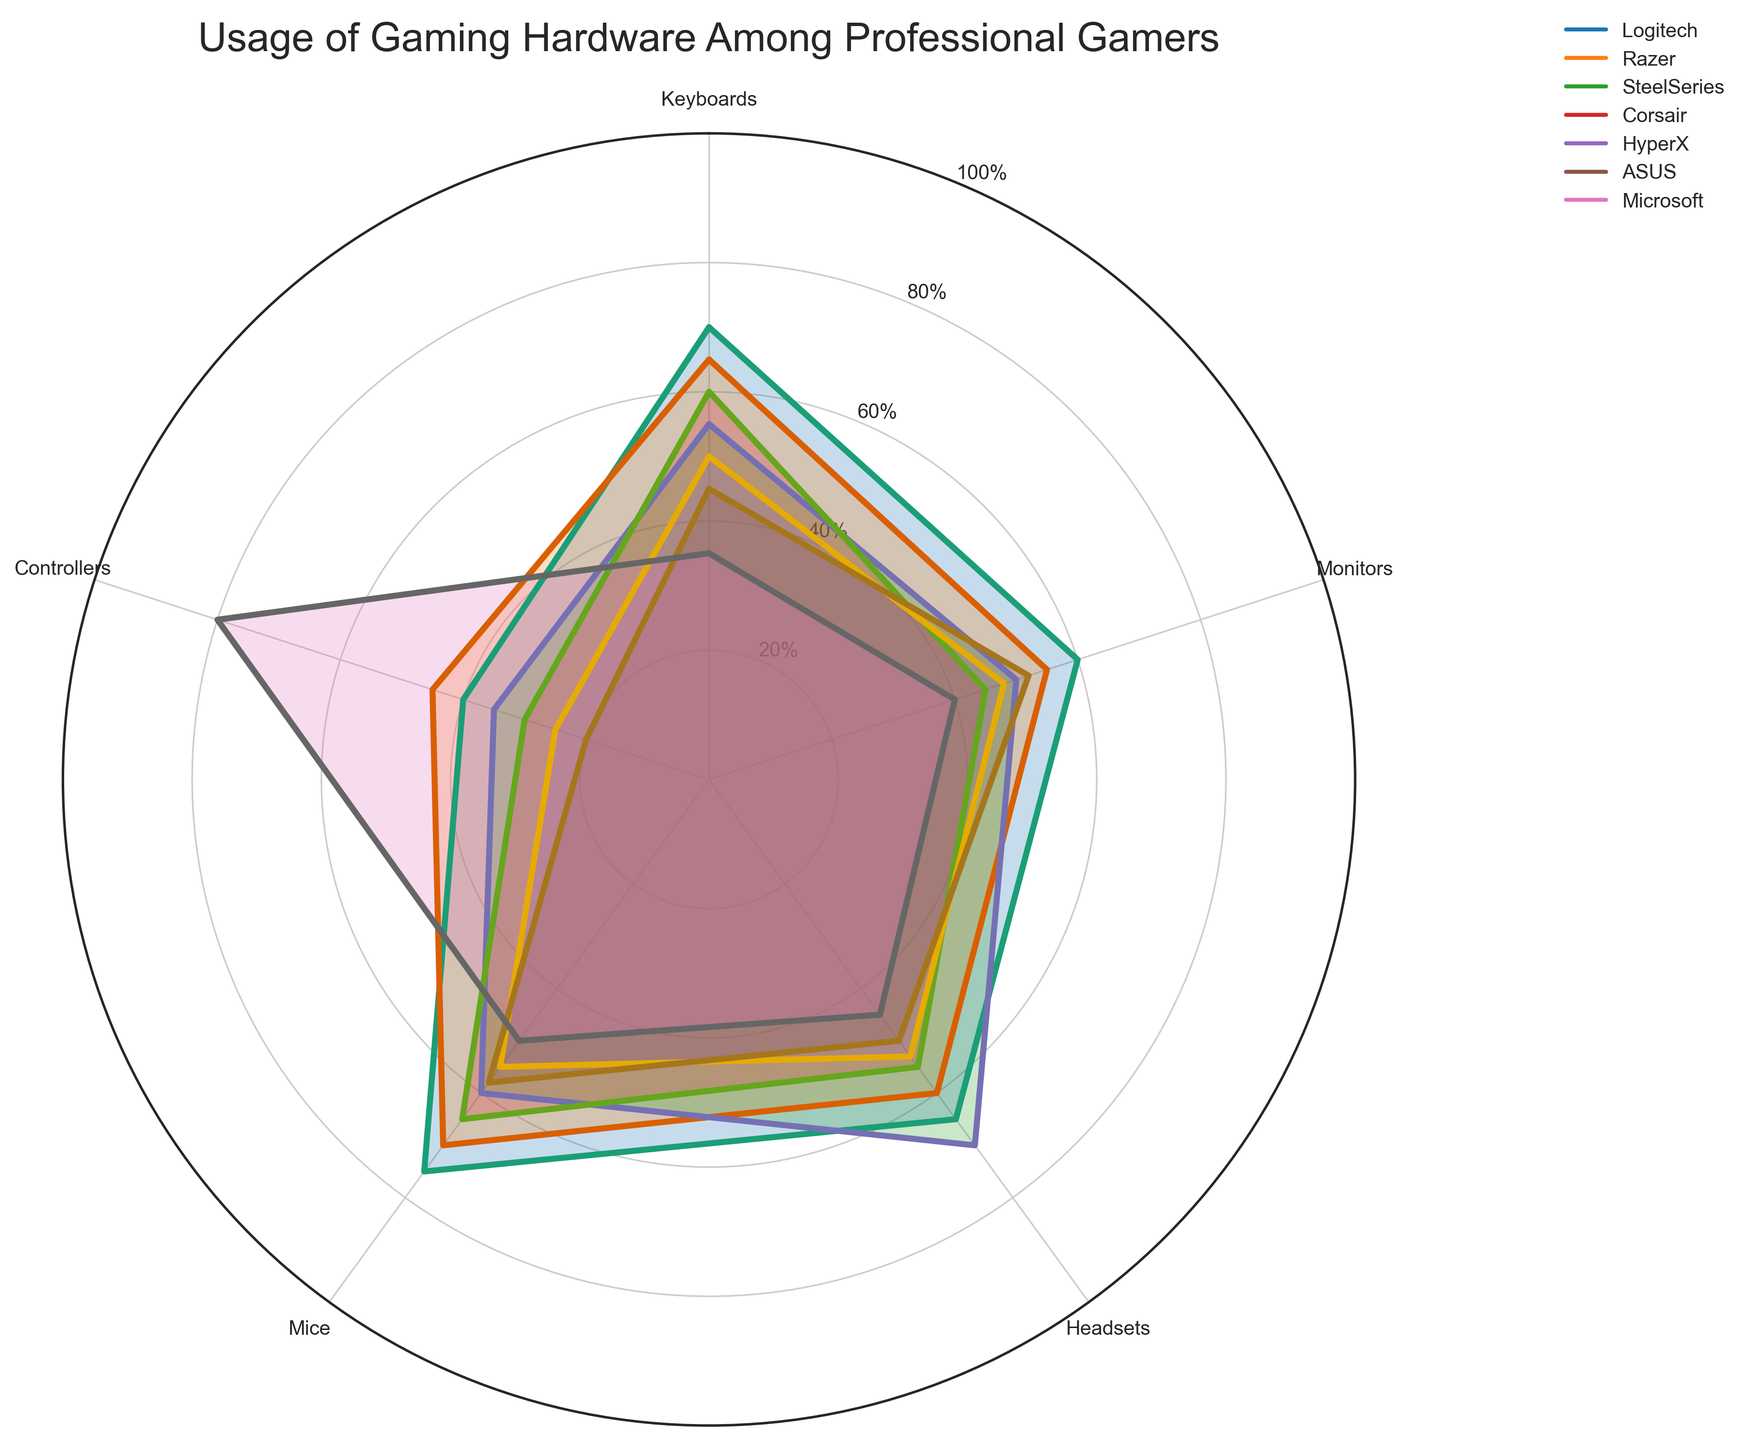How many categories of gaming hardware and peripherals are shown in the figure? The figure displays the different categories as labels around the polar chart. Counting these labels shows how many categories are present. There are five distinct categories: Keyboards, Monitors, Headsets, Mice, and Controllers.
Answer: 5 Which brand is the most popular for gaming keyboards among professional gamers? The angle representing 'Keyboards' shows the percentage usage for each brand. The brand with the highest value at this angle is Logitech, with a usage percentage of 70%.
Answer: Logitech Which category does Microsoft dominate in professional gaming hardware and peripherals? By examining the angles for each category and looking for the highest percentage value for Microsoft, we see that Microsoft leads in 'Controllers' with a percentage of 80%.
Answer: Controllers How does the usage of mice compare between Logitech and Razer? At the angle representing 'Mice', we compare the values for Logitech and Razer. Logitech has a value of 75%, whereas Razer has a value of 70%. Hence, Logitech has a higher usage percentage than Razer.
Answer: Logitech has a higher usage Among the listed brands, which has the lowest usage percentage for headsets? By observing the angle for 'Headsets', the brand with the lowest percentage is ASUS at 50%.
Answer: ASUS What is the overall usage trend for Corsair across all categories compared to HyperX? For Corsair, the usage percentages are 60, 45, 55, 65, and 30 across the categories. For HyperX, they are 50, 48, 53, 55, and 25. Comparing each corresponding category, Corsair generally has higher usage percentages than HyperX except for 'Monitors'.
Answer: Corsair generally has higher usage Is the usage of gaming headsets for SteelSeries higher or lower than for Logitech? Looking at the 'Headsets' angle, SteelSeries has a usage percentage of 70%, and Logitech has a usage percentage of 65%. Thus, SteelSeries has a higher usage percentage for gaming headsets than Logitech.
Answer: Higher What are the average usage percentages of all peripherals for the brand ASUS? Summing the usage percentages for ASUS across all categories: 45 + 52 + 50 + 58 + 20 = 225. Dividing by the number of categories (5) gives the average: 225 / 5 = 45%.
Answer: 45% Which brand has the most balanced usage across all categories? A balanced usage is indicated by relatively even percentages across all categories without large deviations. Corsair has values 60, 45, 55, 65, and 30, showing a more consistent usage pattern compared to the other brands.
Answer: Corsair What is the difference in usage percentages for Corsair and HyperX in the 'Monitors' category? The usage percentage for Corsair in the 'Monitors' category is 45%, and for HyperX, it is 48%. The difference is 48% - 45% = 3%.
Answer: 3% 